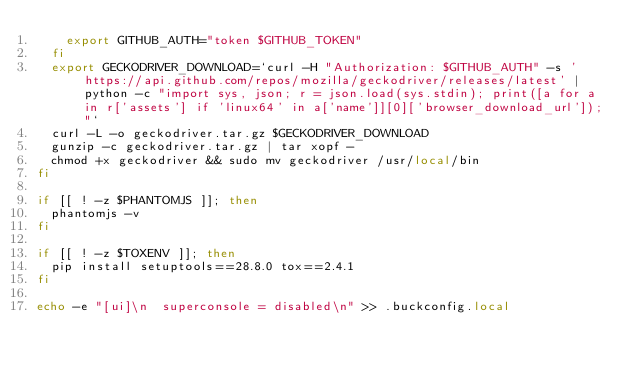<code> <loc_0><loc_0><loc_500><loc_500><_Bash_>    export GITHUB_AUTH="token $GITHUB_TOKEN"
  fi
  export GECKODRIVER_DOWNLOAD=`curl -H "Authorization: $GITHUB_AUTH" -s 'https://api.github.com/repos/mozilla/geckodriver/releases/latest' | python -c "import sys, json; r = json.load(sys.stdin); print([a for a in r['assets'] if 'linux64' in a['name']][0]['browser_download_url']);"`
  curl -L -o geckodriver.tar.gz $GECKODRIVER_DOWNLOAD
  gunzip -c geckodriver.tar.gz | tar xopf -
  chmod +x geckodriver && sudo mv geckodriver /usr/local/bin
fi

if [[ ! -z $PHANTOMJS ]]; then
  phantomjs -v
fi

if [[ ! -z $TOXENV ]]; then
  pip install setuptools==28.8.0 tox==2.4.1
fi

echo -e "[ui]\n  superconsole = disabled\n" >> .buckconfig.local
</code> 